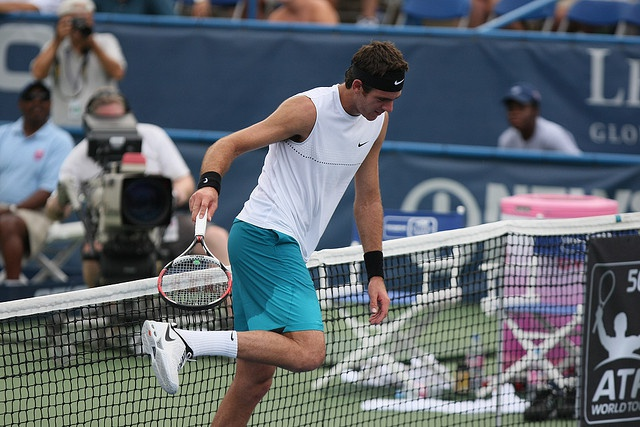Describe the objects in this image and their specific colors. I can see people in darkgray, lavender, brown, and black tones, chair in darkgray, lightgray, gray, and black tones, people in darkgray, gray, lightgray, and black tones, people in darkgray, lightblue, black, and gray tones, and people in darkgray, gray, maroon, and black tones in this image. 